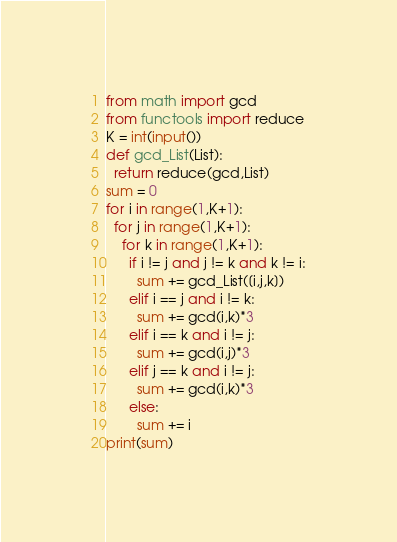Convert code to text. <code><loc_0><loc_0><loc_500><loc_500><_Python_>from math import gcd
from functools import reduce
K = int(input())
def gcd_List(List):
  return reduce(gcd,List)
sum = 0
for i in range(1,K+1):
  for j in range(1,K+1):
    for k in range(1,K+1):
      if i != j and j != k and k != i:
        sum += gcd_List([i,j,k])
      elif i == j and i != k:
        sum += gcd(i,k)*3
      elif i == k and i != j:
        sum += gcd(i,j)*3
      elif j == k and i != j:
        sum += gcd(i,k)*3
      else:
        sum += i
print(sum)
</code> 